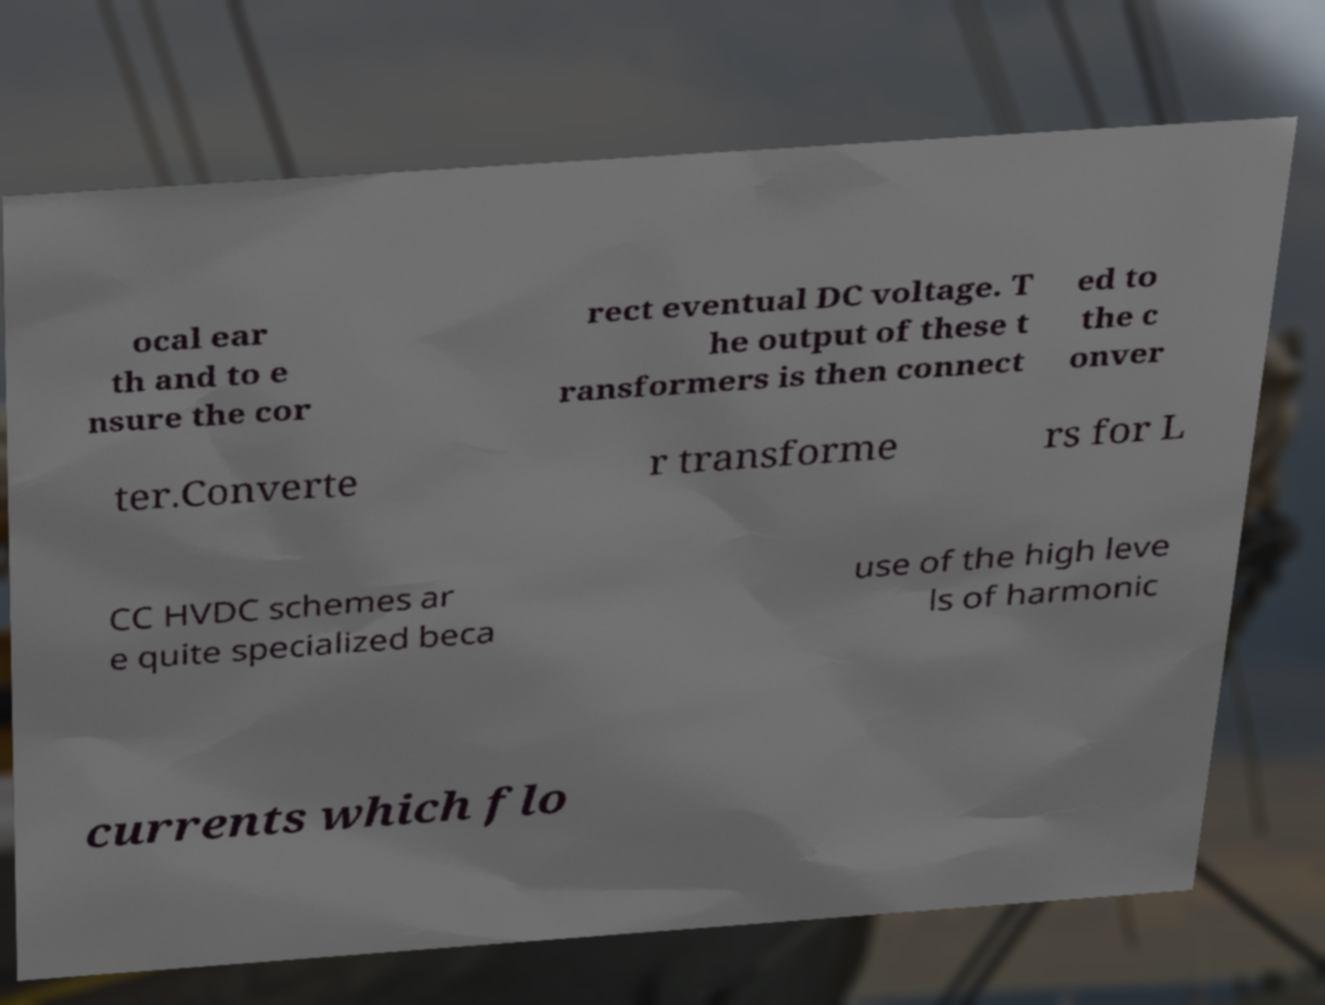Could you assist in decoding the text presented in this image and type it out clearly? ocal ear th and to e nsure the cor rect eventual DC voltage. T he output of these t ransformers is then connect ed to the c onver ter.Converte r transforme rs for L CC HVDC schemes ar e quite specialized beca use of the high leve ls of harmonic currents which flo 